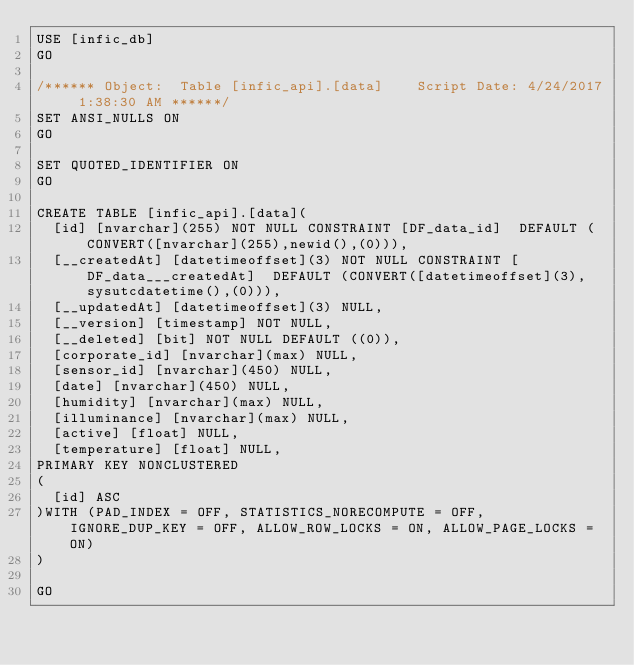Convert code to text. <code><loc_0><loc_0><loc_500><loc_500><_SQL_>USE [infic_db]
GO

/****** Object:  Table [infic_api].[data]    Script Date: 4/24/2017 1:38:30 AM ******/
SET ANSI_NULLS ON
GO

SET QUOTED_IDENTIFIER ON
GO

CREATE TABLE [infic_api].[data](
	[id] [nvarchar](255) NOT NULL CONSTRAINT [DF_data_id]  DEFAULT (CONVERT([nvarchar](255),newid(),(0))),
	[__createdAt] [datetimeoffset](3) NOT NULL CONSTRAINT [DF_data___createdAt]  DEFAULT (CONVERT([datetimeoffset](3),sysutcdatetime(),(0))),
	[__updatedAt] [datetimeoffset](3) NULL,
	[__version] [timestamp] NOT NULL,
	[__deleted] [bit] NOT NULL DEFAULT ((0)),
	[corporate_id] [nvarchar](max) NULL,
	[sensor_id] [nvarchar](450) NULL,
	[date] [nvarchar](450) NULL,
	[humidity] [nvarchar](max) NULL,
	[illuminance] [nvarchar](max) NULL,
	[active] [float] NULL,
	[temperature] [float] NULL,
PRIMARY KEY NONCLUSTERED 
(
	[id] ASC
)WITH (PAD_INDEX = OFF, STATISTICS_NORECOMPUTE = OFF, IGNORE_DUP_KEY = OFF, ALLOW_ROW_LOCKS = ON, ALLOW_PAGE_LOCKS = ON)
)

GO

</code> 